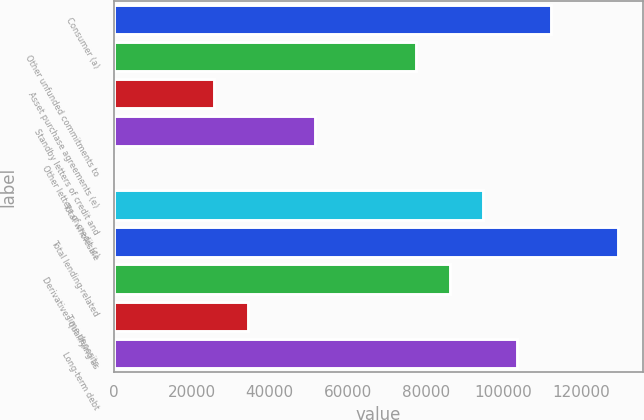Convert chart. <chart><loc_0><loc_0><loc_500><loc_500><bar_chart><fcel>Consumer (a)<fcel>Other unfunded commitments to<fcel>Asset purchase agreements (e)<fcel>Standby letters of credit and<fcel>Other letters of credit (c)<fcel>Total wholesale<fcel>Total lending-related<fcel>Derivatives qualifying as<fcel>Time deposits<fcel>Long-term debt<nl><fcel>112060<fcel>77582.5<fcel>25865.5<fcel>51724<fcel>7<fcel>94821.5<fcel>129300<fcel>86202<fcel>34485<fcel>103441<nl></chart> 